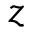<formula> <loc_0><loc_0><loc_500><loc_500>z</formula> 